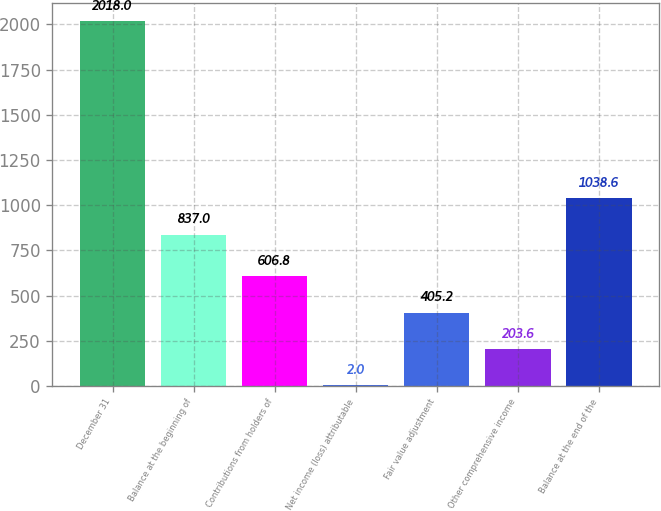Convert chart to OTSL. <chart><loc_0><loc_0><loc_500><loc_500><bar_chart><fcel>December 31<fcel>Balance at the beginning of<fcel>Contributions from holders of<fcel>Net income (loss) attributable<fcel>Fair value adjustment<fcel>Other comprehensive income<fcel>Balance at the end of the<nl><fcel>2018<fcel>837<fcel>606.8<fcel>2<fcel>405.2<fcel>203.6<fcel>1038.6<nl></chart> 